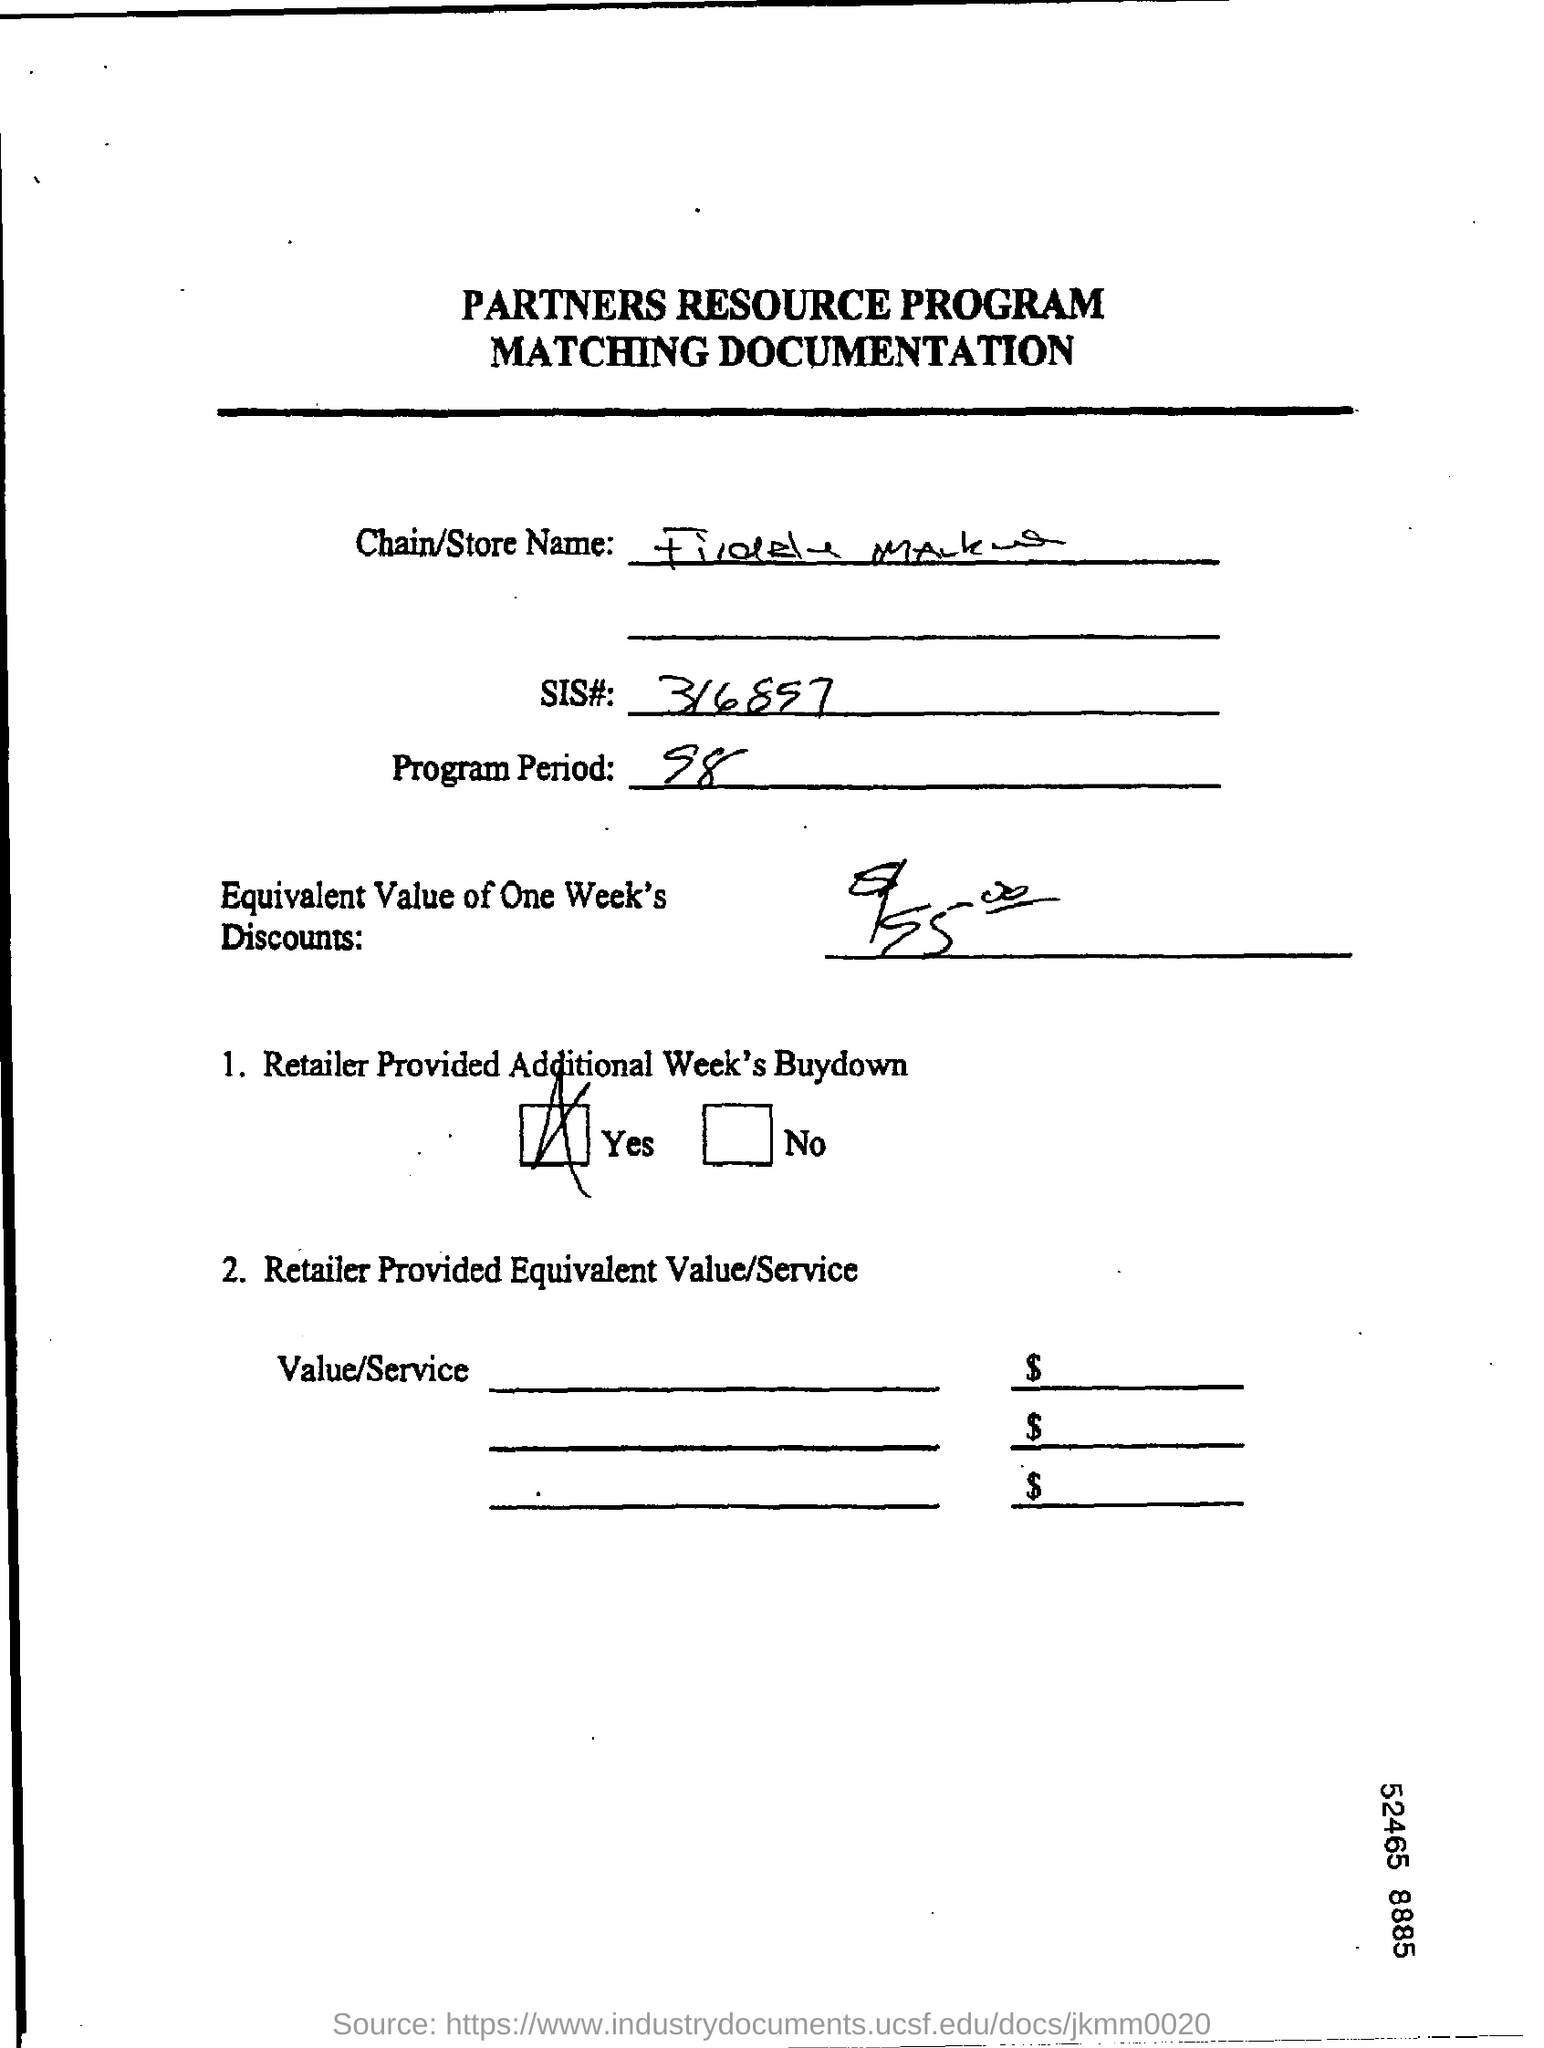Outline some significant characteristics in this image. The question "What is the SIS#?" is asking for information about a specific identification number, specifically 316897. The program period is 98... 